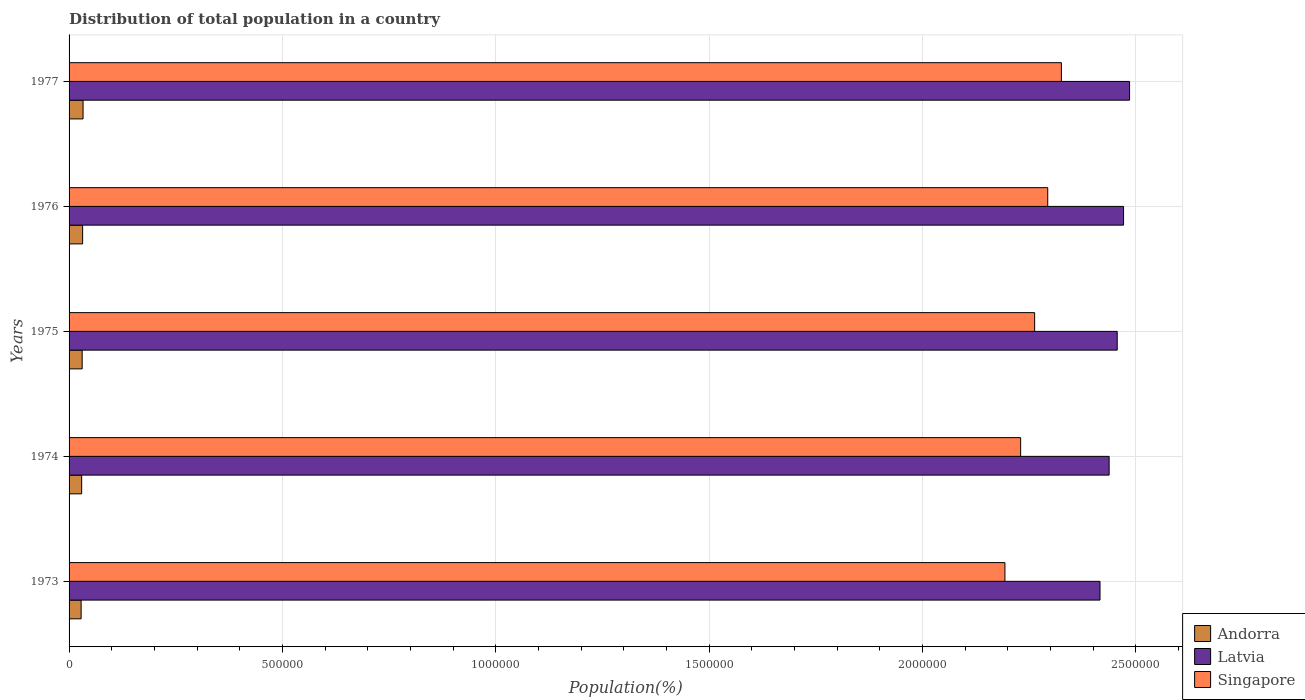How many groups of bars are there?
Your answer should be very brief. 5. Are the number of bars per tick equal to the number of legend labels?
Your response must be concise. Yes. Are the number of bars on each tick of the Y-axis equal?
Offer a very short reply. Yes. How many bars are there on the 4th tick from the bottom?
Provide a short and direct response. 3. What is the label of the 1st group of bars from the top?
Offer a very short reply. 1977. What is the population of in Andorra in 1974?
Ensure brevity in your answer.  2.95e+04. Across all years, what is the maximum population of in Andorra?
Your answer should be very brief. 3.28e+04. Across all years, what is the minimum population of in Andorra?
Make the answer very short. 2.82e+04. In which year was the population of in Andorra minimum?
Your answer should be compact. 1973. What is the total population of in Singapore in the graph?
Offer a very short reply. 1.13e+07. What is the difference between the population of in Singapore in 1973 and that in 1975?
Your answer should be compact. -6.96e+04. What is the difference between the population of in Singapore in 1976 and the population of in Latvia in 1974?
Your answer should be very brief. -1.44e+05. What is the average population of in Latvia per year?
Offer a terse response. 2.45e+06. In the year 1973, what is the difference between the population of in Andorra and population of in Latvia?
Your answer should be very brief. -2.39e+06. What is the ratio of the population of in Singapore in 1974 to that in 1976?
Your response must be concise. 0.97. What is the difference between the highest and the second highest population of in Andorra?
Provide a short and direct response. 988. What is the difference between the highest and the lowest population of in Andorra?
Your answer should be compact. 4538. In how many years, is the population of in Andorra greater than the average population of in Andorra taken over all years?
Your answer should be compact. 3. Is the sum of the population of in Singapore in 1975 and 1976 greater than the maximum population of in Andorra across all years?
Give a very brief answer. Yes. What does the 2nd bar from the top in 1975 represents?
Provide a short and direct response. Latvia. What does the 1st bar from the bottom in 1974 represents?
Your answer should be very brief. Andorra. How many years are there in the graph?
Offer a terse response. 5. What is the difference between two consecutive major ticks on the X-axis?
Make the answer very short. 5.00e+05. Does the graph contain any zero values?
Give a very brief answer. No. Does the graph contain grids?
Offer a terse response. Yes. Where does the legend appear in the graph?
Provide a short and direct response. Bottom right. How many legend labels are there?
Offer a very short reply. 3. How are the legend labels stacked?
Make the answer very short. Vertical. What is the title of the graph?
Give a very brief answer. Distribution of total population in a country. What is the label or title of the X-axis?
Provide a short and direct response. Population(%). What is the label or title of the Y-axis?
Offer a terse response. Years. What is the Population(%) of Andorra in 1973?
Keep it short and to the point. 2.82e+04. What is the Population(%) in Latvia in 1973?
Make the answer very short. 2.42e+06. What is the Population(%) of Singapore in 1973?
Your answer should be very brief. 2.19e+06. What is the Population(%) in Andorra in 1974?
Keep it short and to the point. 2.95e+04. What is the Population(%) of Latvia in 1974?
Make the answer very short. 2.44e+06. What is the Population(%) in Singapore in 1974?
Give a very brief answer. 2.23e+06. What is the Population(%) of Andorra in 1975?
Make the answer very short. 3.07e+04. What is the Population(%) in Latvia in 1975?
Offer a very short reply. 2.46e+06. What is the Population(%) in Singapore in 1975?
Your response must be concise. 2.26e+06. What is the Population(%) of Andorra in 1976?
Give a very brief answer. 3.18e+04. What is the Population(%) in Latvia in 1976?
Make the answer very short. 2.47e+06. What is the Population(%) of Singapore in 1976?
Provide a short and direct response. 2.29e+06. What is the Population(%) of Andorra in 1977?
Provide a succinct answer. 3.28e+04. What is the Population(%) in Latvia in 1977?
Ensure brevity in your answer.  2.49e+06. What is the Population(%) in Singapore in 1977?
Your response must be concise. 2.33e+06. Across all years, what is the maximum Population(%) of Andorra?
Offer a very short reply. 3.28e+04. Across all years, what is the maximum Population(%) in Latvia?
Provide a short and direct response. 2.49e+06. Across all years, what is the maximum Population(%) of Singapore?
Provide a short and direct response. 2.33e+06. Across all years, what is the minimum Population(%) of Andorra?
Make the answer very short. 2.82e+04. Across all years, what is the minimum Population(%) in Latvia?
Ensure brevity in your answer.  2.42e+06. Across all years, what is the minimum Population(%) of Singapore?
Keep it short and to the point. 2.19e+06. What is the total Population(%) in Andorra in the graph?
Ensure brevity in your answer.  1.53e+05. What is the total Population(%) in Latvia in the graph?
Make the answer very short. 1.23e+07. What is the total Population(%) in Singapore in the graph?
Your answer should be very brief. 1.13e+07. What is the difference between the Population(%) of Andorra in 1973 and that in 1974?
Offer a very short reply. -1283. What is the difference between the Population(%) in Latvia in 1973 and that in 1974?
Provide a succinct answer. -2.14e+04. What is the difference between the Population(%) in Singapore in 1973 and that in 1974?
Provide a succinct answer. -3.68e+04. What is the difference between the Population(%) of Andorra in 1973 and that in 1975?
Your response must be concise. -2475. What is the difference between the Population(%) in Latvia in 1973 and that in 1975?
Your answer should be very brief. -4.03e+04. What is the difference between the Population(%) of Singapore in 1973 and that in 1975?
Provide a succinct answer. -6.96e+04. What is the difference between the Population(%) of Andorra in 1973 and that in 1976?
Keep it short and to the point. -3550. What is the difference between the Population(%) in Latvia in 1973 and that in 1976?
Make the answer very short. -5.52e+04. What is the difference between the Population(%) in Singapore in 1973 and that in 1976?
Make the answer very short. -1.00e+05. What is the difference between the Population(%) of Andorra in 1973 and that in 1977?
Your response must be concise. -4538. What is the difference between the Population(%) in Latvia in 1973 and that in 1977?
Keep it short and to the point. -6.93e+04. What is the difference between the Population(%) in Singapore in 1973 and that in 1977?
Ensure brevity in your answer.  -1.32e+05. What is the difference between the Population(%) of Andorra in 1974 and that in 1975?
Give a very brief answer. -1192. What is the difference between the Population(%) in Latvia in 1974 and that in 1975?
Offer a terse response. -1.89e+04. What is the difference between the Population(%) of Singapore in 1974 and that in 1975?
Provide a succinct answer. -3.28e+04. What is the difference between the Population(%) of Andorra in 1974 and that in 1976?
Offer a terse response. -2267. What is the difference between the Population(%) of Latvia in 1974 and that in 1976?
Ensure brevity in your answer.  -3.38e+04. What is the difference between the Population(%) of Singapore in 1974 and that in 1976?
Your answer should be very brief. -6.35e+04. What is the difference between the Population(%) of Andorra in 1974 and that in 1977?
Your answer should be very brief. -3255. What is the difference between the Population(%) of Latvia in 1974 and that in 1977?
Provide a succinct answer. -4.79e+04. What is the difference between the Population(%) in Singapore in 1974 and that in 1977?
Keep it short and to the point. -9.55e+04. What is the difference between the Population(%) of Andorra in 1975 and that in 1976?
Give a very brief answer. -1075. What is the difference between the Population(%) of Latvia in 1975 and that in 1976?
Provide a succinct answer. -1.49e+04. What is the difference between the Population(%) of Singapore in 1975 and that in 1976?
Offer a very short reply. -3.07e+04. What is the difference between the Population(%) in Andorra in 1975 and that in 1977?
Give a very brief answer. -2063. What is the difference between the Population(%) in Latvia in 1975 and that in 1977?
Your answer should be very brief. -2.89e+04. What is the difference between the Population(%) in Singapore in 1975 and that in 1977?
Make the answer very short. -6.27e+04. What is the difference between the Population(%) of Andorra in 1976 and that in 1977?
Offer a terse response. -988. What is the difference between the Population(%) in Latvia in 1976 and that in 1977?
Keep it short and to the point. -1.41e+04. What is the difference between the Population(%) of Singapore in 1976 and that in 1977?
Provide a succinct answer. -3.20e+04. What is the difference between the Population(%) in Andorra in 1973 and the Population(%) in Latvia in 1974?
Make the answer very short. -2.41e+06. What is the difference between the Population(%) in Andorra in 1973 and the Population(%) in Singapore in 1974?
Ensure brevity in your answer.  -2.20e+06. What is the difference between the Population(%) in Latvia in 1973 and the Population(%) in Singapore in 1974?
Make the answer very short. 1.86e+05. What is the difference between the Population(%) of Andorra in 1973 and the Population(%) of Latvia in 1975?
Your answer should be compact. -2.43e+06. What is the difference between the Population(%) of Andorra in 1973 and the Population(%) of Singapore in 1975?
Offer a very short reply. -2.23e+06. What is the difference between the Population(%) of Latvia in 1973 and the Population(%) of Singapore in 1975?
Give a very brief answer. 1.53e+05. What is the difference between the Population(%) of Andorra in 1973 and the Population(%) of Latvia in 1976?
Your response must be concise. -2.44e+06. What is the difference between the Population(%) of Andorra in 1973 and the Population(%) of Singapore in 1976?
Provide a succinct answer. -2.27e+06. What is the difference between the Population(%) of Latvia in 1973 and the Population(%) of Singapore in 1976?
Your response must be concise. 1.23e+05. What is the difference between the Population(%) of Andorra in 1973 and the Population(%) of Latvia in 1977?
Ensure brevity in your answer.  -2.46e+06. What is the difference between the Population(%) of Andorra in 1973 and the Population(%) of Singapore in 1977?
Your answer should be very brief. -2.30e+06. What is the difference between the Population(%) in Latvia in 1973 and the Population(%) in Singapore in 1977?
Make the answer very short. 9.05e+04. What is the difference between the Population(%) in Andorra in 1974 and the Population(%) in Latvia in 1975?
Offer a very short reply. -2.43e+06. What is the difference between the Population(%) of Andorra in 1974 and the Population(%) of Singapore in 1975?
Ensure brevity in your answer.  -2.23e+06. What is the difference between the Population(%) of Latvia in 1974 and the Population(%) of Singapore in 1975?
Your response must be concise. 1.75e+05. What is the difference between the Population(%) in Andorra in 1974 and the Population(%) in Latvia in 1976?
Make the answer very short. -2.44e+06. What is the difference between the Population(%) in Andorra in 1974 and the Population(%) in Singapore in 1976?
Your answer should be very brief. -2.26e+06. What is the difference between the Population(%) in Latvia in 1974 and the Population(%) in Singapore in 1976?
Make the answer very short. 1.44e+05. What is the difference between the Population(%) in Andorra in 1974 and the Population(%) in Latvia in 1977?
Make the answer very short. -2.46e+06. What is the difference between the Population(%) in Andorra in 1974 and the Population(%) in Singapore in 1977?
Your answer should be very brief. -2.30e+06. What is the difference between the Population(%) of Latvia in 1974 and the Population(%) of Singapore in 1977?
Offer a terse response. 1.12e+05. What is the difference between the Population(%) of Andorra in 1975 and the Population(%) of Latvia in 1976?
Provide a short and direct response. -2.44e+06. What is the difference between the Population(%) of Andorra in 1975 and the Population(%) of Singapore in 1976?
Your response must be concise. -2.26e+06. What is the difference between the Population(%) in Latvia in 1975 and the Population(%) in Singapore in 1976?
Keep it short and to the point. 1.63e+05. What is the difference between the Population(%) in Andorra in 1975 and the Population(%) in Latvia in 1977?
Give a very brief answer. -2.45e+06. What is the difference between the Population(%) of Andorra in 1975 and the Population(%) of Singapore in 1977?
Your response must be concise. -2.29e+06. What is the difference between the Population(%) of Latvia in 1975 and the Population(%) of Singapore in 1977?
Your answer should be very brief. 1.31e+05. What is the difference between the Population(%) of Andorra in 1976 and the Population(%) of Latvia in 1977?
Keep it short and to the point. -2.45e+06. What is the difference between the Population(%) in Andorra in 1976 and the Population(%) in Singapore in 1977?
Your answer should be compact. -2.29e+06. What is the difference between the Population(%) of Latvia in 1976 and the Population(%) of Singapore in 1977?
Give a very brief answer. 1.46e+05. What is the average Population(%) of Andorra per year?
Your answer should be very brief. 3.06e+04. What is the average Population(%) of Latvia per year?
Your response must be concise. 2.45e+06. What is the average Population(%) in Singapore per year?
Your answer should be very brief. 2.26e+06. In the year 1973, what is the difference between the Population(%) in Andorra and Population(%) in Latvia?
Provide a short and direct response. -2.39e+06. In the year 1973, what is the difference between the Population(%) in Andorra and Population(%) in Singapore?
Your answer should be compact. -2.16e+06. In the year 1973, what is the difference between the Population(%) of Latvia and Population(%) of Singapore?
Provide a succinct answer. 2.23e+05. In the year 1974, what is the difference between the Population(%) in Andorra and Population(%) in Latvia?
Your answer should be compact. -2.41e+06. In the year 1974, what is the difference between the Population(%) of Andorra and Population(%) of Singapore?
Provide a short and direct response. -2.20e+06. In the year 1974, what is the difference between the Population(%) in Latvia and Population(%) in Singapore?
Ensure brevity in your answer.  2.07e+05. In the year 1975, what is the difference between the Population(%) in Andorra and Population(%) in Latvia?
Ensure brevity in your answer.  -2.43e+06. In the year 1975, what is the difference between the Population(%) in Andorra and Population(%) in Singapore?
Provide a short and direct response. -2.23e+06. In the year 1975, what is the difference between the Population(%) in Latvia and Population(%) in Singapore?
Your answer should be very brief. 1.94e+05. In the year 1976, what is the difference between the Population(%) in Andorra and Population(%) in Latvia?
Keep it short and to the point. -2.44e+06. In the year 1976, what is the difference between the Population(%) in Andorra and Population(%) in Singapore?
Provide a succinct answer. -2.26e+06. In the year 1976, what is the difference between the Population(%) of Latvia and Population(%) of Singapore?
Offer a very short reply. 1.78e+05. In the year 1977, what is the difference between the Population(%) of Andorra and Population(%) of Latvia?
Your response must be concise. -2.45e+06. In the year 1977, what is the difference between the Population(%) in Andorra and Population(%) in Singapore?
Offer a very short reply. -2.29e+06. In the year 1977, what is the difference between the Population(%) in Latvia and Population(%) in Singapore?
Provide a short and direct response. 1.60e+05. What is the ratio of the Population(%) in Andorra in 1973 to that in 1974?
Make the answer very short. 0.96. What is the ratio of the Population(%) of Singapore in 1973 to that in 1974?
Your answer should be compact. 0.98. What is the ratio of the Population(%) of Andorra in 1973 to that in 1975?
Give a very brief answer. 0.92. What is the ratio of the Population(%) in Latvia in 1973 to that in 1975?
Keep it short and to the point. 0.98. What is the ratio of the Population(%) of Singapore in 1973 to that in 1975?
Provide a short and direct response. 0.97. What is the ratio of the Population(%) of Andorra in 1973 to that in 1976?
Keep it short and to the point. 0.89. What is the ratio of the Population(%) in Latvia in 1973 to that in 1976?
Provide a succinct answer. 0.98. What is the ratio of the Population(%) of Singapore in 1973 to that in 1976?
Offer a very short reply. 0.96. What is the ratio of the Population(%) in Andorra in 1973 to that in 1977?
Keep it short and to the point. 0.86. What is the ratio of the Population(%) in Latvia in 1973 to that in 1977?
Provide a short and direct response. 0.97. What is the ratio of the Population(%) of Singapore in 1973 to that in 1977?
Your answer should be very brief. 0.94. What is the ratio of the Population(%) of Andorra in 1974 to that in 1975?
Your answer should be compact. 0.96. What is the ratio of the Population(%) of Latvia in 1974 to that in 1975?
Ensure brevity in your answer.  0.99. What is the ratio of the Population(%) in Singapore in 1974 to that in 1975?
Provide a short and direct response. 0.99. What is the ratio of the Population(%) of Andorra in 1974 to that in 1976?
Ensure brevity in your answer.  0.93. What is the ratio of the Population(%) of Latvia in 1974 to that in 1976?
Provide a short and direct response. 0.99. What is the ratio of the Population(%) of Singapore in 1974 to that in 1976?
Provide a short and direct response. 0.97. What is the ratio of the Population(%) of Andorra in 1974 to that in 1977?
Ensure brevity in your answer.  0.9. What is the ratio of the Population(%) of Latvia in 1974 to that in 1977?
Your answer should be compact. 0.98. What is the ratio of the Population(%) of Singapore in 1974 to that in 1977?
Make the answer very short. 0.96. What is the ratio of the Population(%) in Andorra in 1975 to that in 1976?
Offer a very short reply. 0.97. What is the ratio of the Population(%) in Singapore in 1975 to that in 1976?
Your answer should be very brief. 0.99. What is the ratio of the Population(%) of Andorra in 1975 to that in 1977?
Your answer should be very brief. 0.94. What is the ratio of the Population(%) in Latvia in 1975 to that in 1977?
Your answer should be compact. 0.99. What is the ratio of the Population(%) of Andorra in 1976 to that in 1977?
Offer a terse response. 0.97. What is the ratio of the Population(%) in Latvia in 1976 to that in 1977?
Ensure brevity in your answer.  0.99. What is the ratio of the Population(%) in Singapore in 1976 to that in 1977?
Offer a very short reply. 0.99. What is the difference between the highest and the second highest Population(%) in Andorra?
Provide a short and direct response. 988. What is the difference between the highest and the second highest Population(%) in Latvia?
Offer a terse response. 1.41e+04. What is the difference between the highest and the second highest Population(%) of Singapore?
Provide a short and direct response. 3.20e+04. What is the difference between the highest and the lowest Population(%) of Andorra?
Your response must be concise. 4538. What is the difference between the highest and the lowest Population(%) of Latvia?
Your answer should be very brief. 6.93e+04. What is the difference between the highest and the lowest Population(%) of Singapore?
Your answer should be very brief. 1.32e+05. 